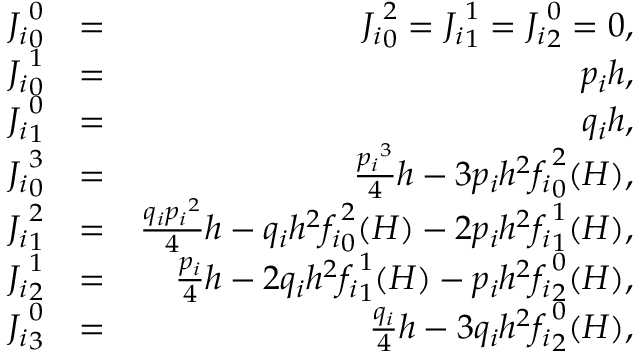Convert formula to latex. <formula><loc_0><loc_0><loc_500><loc_500>\begin{array} { r l r } { { J _ { i } } _ { 0 } ^ { 0 } } & { = } & { { J _ { i } } _ { 0 } ^ { 2 } = { J _ { i } } _ { 1 } ^ { 1 } = { J _ { i } } _ { 2 } ^ { 0 } = 0 , } \\ { { J _ { i } } _ { 0 } ^ { 1 } } & { = } & { p _ { i } h , } \\ { { J _ { i } } _ { 1 } ^ { 0 } } & { = } & { q _ { i } h , } \\ { { J _ { i } } _ { 0 } ^ { 3 } } & { = } & { \frac { { p _ { i } } ^ { 3 } } { 4 } h - 3 p _ { i } h ^ { 2 } { f _ { i } } _ { 0 } ^ { 2 } ( H ) , } \\ { { J _ { i } } _ { 1 } ^ { 2 } } & { = } & { \frac { q _ { i } { p _ { i } } ^ { 2 } } { 4 } h - q _ { i } h ^ { 2 } { f _ { i } } _ { 0 } ^ { 2 } ( H ) - 2 p _ { i } h ^ { 2 } { f _ { i } } _ { 1 } ^ { 1 } ( H ) , } \\ { { J _ { i } } _ { 2 } ^ { 1 } } & { = } & { \frac { p _ { i } } { 4 } h - 2 q _ { i } h ^ { 2 } { f _ { i } } _ { 1 } ^ { 1 } ( H ) - p _ { i } h ^ { 2 } { f _ { i } } _ { 2 } ^ { 0 } ( H ) , } \\ { { J _ { i } } _ { 3 } ^ { 0 } } & { = } & { \frac { q _ { i } } { 4 } h - 3 q _ { i } h ^ { 2 } { f _ { i } } _ { 2 } ^ { 0 } ( H ) , } \end{array}</formula> 